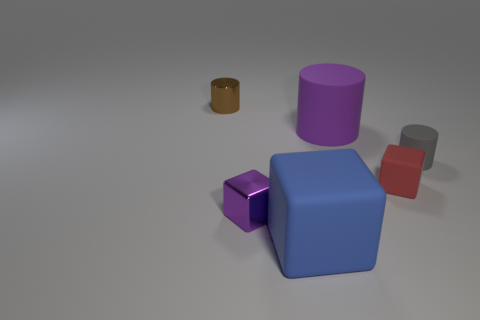Subtract all big purple rubber cylinders. How many cylinders are left? 2 Add 2 purple cylinders. How many objects exist? 8 Subtract all large purple rubber cylinders. Subtract all gray matte spheres. How many objects are left? 5 Add 2 small brown things. How many small brown things are left? 3 Add 2 tiny brown cylinders. How many tiny brown cylinders exist? 3 Subtract 1 brown cylinders. How many objects are left? 5 Subtract 2 cubes. How many cubes are left? 1 Subtract all brown blocks. Subtract all green spheres. How many blocks are left? 3 